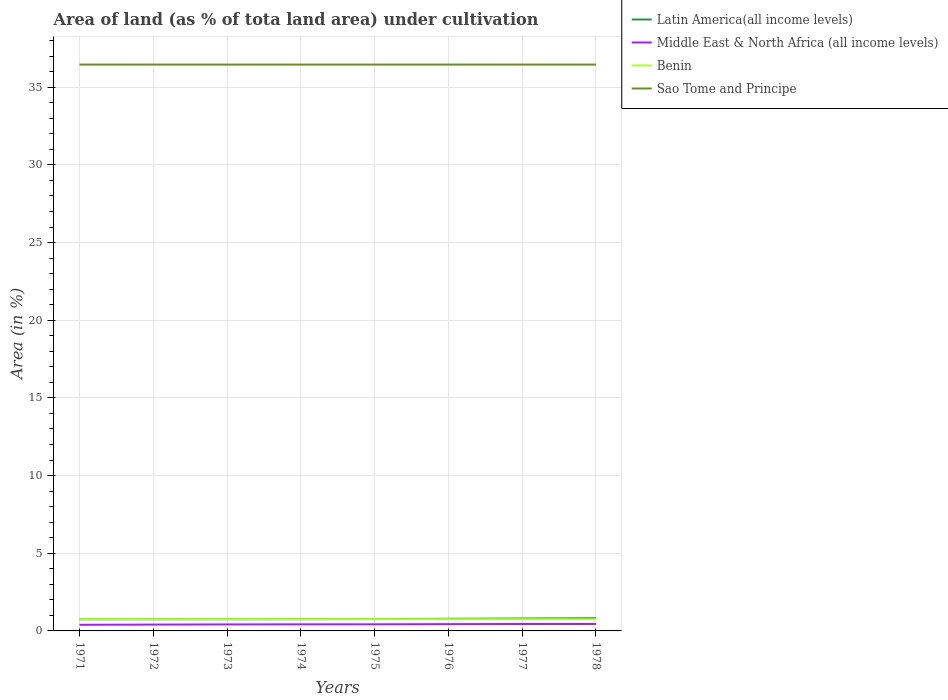Does the line corresponding to Middle East & North Africa (all income levels) intersect with the line corresponding to Latin America(all income levels)?
Give a very brief answer. No. Across all years, what is the maximum percentage of land under cultivation in Middle East & North Africa (all income levels)?
Make the answer very short. 0.39. What is the total percentage of land under cultivation in Latin America(all income levels) in the graph?
Provide a short and direct response. -0.06. What is the difference between the highest and the second highest percentage of land under cultivation in Latin America(all income levels)?
Provide a short and direct response. 0.07. Is the percentage of land under cultivation in Middle East & North Africa (all income levels) strictly greater than the percentage of land under cultivation in Benin over the years?
Your answer should be compact. Yes. How many lines are there?
Offer a very short reply. 4. How many years are there in the graph?
Your response must be concise. 8. What is the difference between two consecutive major ticks on the Y-axis?
Offer a terse response. 5. Does the graph contain any zero values?
Provide a short and direct response. No. Where does the legend appear in the graph?
Offer a terse response. Top right. How many legend labels are there?
Keep it short and to the point. 4. What is the title of the graph?
Ensure brevity in your answer.  Area of land (as % of tota land area) under cultivation. Does "Turkey" appear as one of the legend labels in the graph?
Offer a very short reply. No. What is the label or title of the X-axis?
Ensure brevity in your answer.  Years. What is the label or title of the Y-axis?
Provide a succinct answer. Area (in %). What is the Area (in %) in Latin America(all income levels) in 1971?
Ensure brevity in your answer.  0.75. What is the Area (in %) in Middle East & North Africa (all income levels) in 1971?
Make the answer very short. 0.39. What is the Area (in %) of Benin in 1971?
Keep it short and to the point. 0.75. What is the Area (in %) in Sao Tome and Principe in 1971?
Ensure brevity in your answer.  36.46. What is the Area (in %) of Latin America(all income levels) in 1972?
Your answer should be compact. 0.75. What is the Area (in %) of Middle East & North Africa (all income levels) in 1972?
Your answer should be compact. 0.41. What is the Area (in %) in Benin in 1972?
Keep it short and to the point. 0.75. What is the Area (in %) of Sao Tome and Principe in 1972?
Your response must be concise. 36.46. What is the Area (in %) of Latin America(all income levels) in 1973?
Provide a succinct answer. 0.76. What is the Area (in %) of Middle East & North Africa (all income levels) in 1973?
Give a very brief answer. 0.42. What is the Area (in %) in Benin in 1973?
Your response must be concise. 0.75. What is the Area (in %) of Sao Tome and Principe in 1973?
Offer a terse response. 36.46. What is the Area (in %) in Latin America(all income levels) in 1974?
Give a very brief answer. 0.76. What is the Area (in %) of Middle East & North Africa (all income levels) in 1974?
Your response must be concise. 0.42. What is the Area (in %) of Benin in 1974?
Make the answer very short. 0.75. What is the Area (in %) of Sao Tome and Principe in 1974?
Ensure brevity in your answer.  36.46. What is the Area (in %) in Latin America(all income levels) in 1975?
Provide a succinct answer. 0.76. What is the Area (in %) in Middle East & North Africa (all income levels) in 1975?
Your answer should be compact. 0.42. What is the Area (in %) of Benin in 1975?
Give a very brief answer. 0.75. What is the Area (in %) of Sao Tome and Principe in 1975?
Ensure brevity in your answer.  36.46. What is the Area (in %) of Latin America(all income levels) in 1976?
Keep it short and to the point. 0.78. What is the Area (in %) of Middle East & North Africa (all income levels) in 1976?
Give a very brief answer. 0.44. What is the Area (in %) of Benin in 1976?
Offer a very short reply. 0.75. What is the Area (in %) in Sao Tome and Principe in 1976?
Your answer should be very brief. 36.46. What is the Area (in %) of Latin America(all income levels) in 1977?
Your answer should be compact. 0.8. What is the Area (in %) in Middle East & North Africa (all income levels) in 1977?
Offer a terse response. 0.45. What is the Area (in %) in Benin in 1977?
Make the answer very short. 0.75. What is the Area (in %) in Sao Tome and Principe in 1977?
Your answer should be compact. 36.46. What is the Area (in %) of Latin America(all income levels) in 1978?
Your response must be concise. 0.82. What is the Area (in %) of Middle East & North Africa (all income levels) in 1978?
Offer a terse response. 0.45. What is the Area (in %) in Benin in 1978?
Ensure brevity in your answer.  0.75. What is the Area (in %) of Sao Tome and Principe in 1978?
Offer a very short reply. 36.46. Across all years, what is the maximum Area (in %) in Latin America(all income levels)?
Your answer should be very brief. 0.82. Across all years, what is the maximum Area (in %) in Middle East & North Africa (all income levels)?
Provide a short and direct response. 0.45. Across all years, what is the maximum Area (in %) in Benin?
Your response must be concise. 0.75. Across all years, what is the maximum Area (in %) of Sao Tome and Principe?
Your answer should be very brief. 36.46. Across all years, what is the minimum Area (in %) of Latin America(all income levels)?
Make the answer very short. 0.75. Across all years, what is the minimum Area (in %) of Middle East & North Africa (all income levels)?
Your answer should be very brief. 0.39. Across all years, what is the minimum Area (in %) of Benin?
Offer a very short reply. 0.75. Across all years, what is the minimum Area (in %) in Sao Tome and Principe?
Provide a short and direct response. 36.46. What is the total Area (in %) of Latin America(all income levels) in the graph?
Provide a short and direct response. 6.18. What is the total Area (in %) of Middle East & North Africa (all income levels) in the graph?
Provide a succinct answer. 3.39. What is the total Area (in %) of Benin in the graph?
Keep it short and to the point. 6.03. What is the total Area (in %) of Sao Tome and Principe in the graph?
Offer a very short reply. 291.67. What is the difference between the Area (in %) in Latin America(all income levels) in 1971 and that in 1972?
Your answer should be compact. -0. What is the difference between the Area (in %) in Middle East & North Africa (all income levels) in 1971 and that in 1972?
Provide a succinct answer. -0.01. What is the difference between the Area (in %) of Latin America(all income levels) in 1971 and that in 1973?
Keep it short and to the point. -0.01. What is the difference between the Area (in %) of Middle East & North Africa (all income levels) in 1971 and that in 1973?
Offer a very short reply. -0.02. What is the difference between the Area (in %) of Benin in 1971 and that in 1973?
Make the answer very short. 0. What is the difference between the Area (in %) of Latin America(all income levels) in 1971 and that in 1974?
Keep it short and to the point. -0.01. What is the difference between the Area (in %) of Middle East & North Africa (all income levels) in 1971 and that in 1974?
Give a very brief answer. -0.03. What is the difference between the Area (in %) in Latin America(all income levels) in 1971 and that in 1975?
Your answer should be very brief. -0.01. What is the difference between the Area (in %) in Middle East & North Africa (all income levels) in 1971 and that in 1975?
Make the answer very short. -0.03. What is the difference between the Area (in %) in Latin America(all income levels) in 1971 and that in 1976?
Make the answer very short. -0.03. What is the difference between the Area (in %) of Middle East & North Africa (all income levels) in 1971 and that in 1976?
Your answer should be very brief. -0.04. What is the difference between the Area (in %) of Benin in 1971 and that in 1976?
Give a very brief answer. 0. What is the difference between the Area (in %) in Latin America(all income levels) in 1971 and that in 1977?
Your response must be concise. -0.05. What is the difference between the Area (in %) in Middle East & North Africa (all income levels) in 1971 and that in 1977?
Offer a terse response. -0.05. What is the difference between the Area (in %) in Benin in 1971 and that in 1977?
Offer a very short reply. 0. What is the difference between the Area (in %) in Sao Tome and Principe in 1971 and that in 1977?
Your answer should be compact. 0. What is the difference between the Area (in %) of Latin America(all income levels) in 1971 and that in 1978?
Your answer should be compact. -0.07. What is the difference between the Area (in %) of Middle East & North Africa (all income levels) in 1971 and that in 1978?
Provide a short and direct response. -0.05. What is the difference between the Area (in %) of Sao Tome and Principe in 1971 and that in 1978?
Give a very brief answer. 0. What is the difference between the Area (in %) of Latin America(all income levels) in 1972 and that in 1973?
Your answer should be compact. -0. What is the difference between the Area (in %) in Middle East & North Africa (all income levels) in 1972 and that in 1973?
Give a very brief answer. -0.01. What is the difference between the Area (in %) of Benin in 1972 and that in 1973?
Provide a succinct answer. 0. What is the difference between the Area (in %) in Latin America(all income levels) in 1972 and that in 1974?
Ensure brevity in your answer.  -0. What is the difference between the Area (in %) in Middle East & North Africa (all income levels) in 1972 and that in 1974?
Your response must be concise. -0.02. What is the difference between the Area (in %) in Sao Tome and Principe in 1972 and that in 1974?
Your response must be concise. 0. What is the difference between the Area (in %) of Latin America(all income levels) in 1972 and that in 1975?
Make the answer very short. -0.01. What is the difference between the Area (in %) of Middle East & North Africa (all income levels) in 1972 and that in 1975?
Your response must be concise. -0.02. What is the difference between the Area (in %) in Latin America(all income levels) in 1972 and that in 1976?
Offer a very short reply. -0.03. What is the difference between the Area (in %) in Middle East & North Africa (all income levels) in 1972 and that in 1976?
Your answer should be very brief. -0.03. What is the difference between the Area (in %) in Benin in 1972 and that in 1976?
Offer a terse response. 0. What is the difference between the Area (in %) of Latin America(all income levels) in 1972 and that in 1977?
Your answer should be very brief. -0.04. What is the difference between the Area (in %) in Middle East & North Africa (all income levels) in 1972 and that in 1977?
Keep it short and to the point. -0.04. What is the difference between the Area (in %) in Benin in 1972 and that in 1977?
Offer a terse response. 0. What is the difference between the Area (in %) of Latin America(all income levels) in 1972 and that in 1978?
Ensure brevity in your answer.  -0.06. What is the difference between the Area (in %) in Middle East & North Africa (all income levels) in 1972 and that in 1978?
Keep it short and to the point. -0.04. What is the difference between the Area (in %) in Benin in 1972 and that in 1978?
Provide a succinct answer. 0. What is the difference between the Area (in %) in Sao Tome and Principe in 1972 and that in 1978?
Your answer should be very brief. 0. What is the difference between the Area (in %) in Latin America(all income levels) in 1973 and that in 1974?
Keep it short and to the point. -0. What is the difference between the Area (in %) of Middle East & North Africa (all income levels) in 1973 and that in 1974?
Give a very brief answer. -0.01. What is the difference between the Area (in %) of Benin in 1973 and that in 1974?
Give a very brief answer. 0. What is the difference between the Area (in %) in Latin America(all income levels) in 1973 and that in 1975?
Give a very brief answer. -0.01. What is the difference between the Area (in %) of Middle East & North Africa (all income levels) in 1973 and that in 1975?
Your answer should be compact. -0.01. What is the difference between the Area (in %) of Benin in 1973 and that in 1975?
Ensure brevity in your answer.  0. What is the difference between the Area (in %) in Latin America(all income levels) in 1973 and that in 1976?
Offer a terse response. -0.03. What is the difference between the Area (in %) in Middle East & North Africa (all income levels) in 1973 and that in 1976?
Provide a succinct answer. -0.02. What is the difference between the Area (in %) in Benin in 1973 and that in 1976?
Offer a very short reply. 0. What is the difference between the Area (in %) of Sao Tome and Principe in 1973 and that in 1976?
Provide a short and direct response. 0. What is the difference between the Area (in %) of Latin America(all income levels) in 1973 and that in 1977?
Keep it short and to the point. -0.04. What is the difference between the Area (in %) in Middle East & North Africa (all income levels) in 1973 and that in 1977?
Keep it short and to the point. -0.03. What is the difference between the Area (in %) of Benin in 1973 and that in 1977?
Your response must be concise. 0. What is the difference between the Area (in %) in Sao Tome and Principe in 1973 and that in 1977?
Your answer should be very brief. 0. What is the difference between the Area (in %) in Latin America(all income levels) in 1973 and that in 1978?
Ensure brevity in your answer.  -0.06. What is the difference between the Area (in %) in Middle East & North Africa (all income levels) in 1973 and that in 1978?
Your answer should be very brief. -0.03. What is the difference between the Area (in %) in Benin in 1973 and that in 1978?
Your answer should be very brief. 0. What is the difference between the Area (in %) in Latin America(all income levels) in 1974 and that in 1975?
Your answer should be very brief. -0.01. What is the difference between the Area (in %) of Middle East & North Africa (all income levels) in 1974 and that in 1975?
Offer a terse response. -0. What is the difference between the Area (in %) of Latin America(all income levels) in 1974 and that in 1976?
Your answer should be very brief. -0.02. What is the difference between the Area (in %) in Middle East & North Africa (all income levels) in 1974 and that in 1976?
Your response must be concise. -0.01. What is the difference between the Area (in %) in Benin in 1974 and that in 1976?
Your answer should be very brief. 0. What is the difference between the Area (in %) in Latin America(all income levels) in 1974 and that in 1977?
Make the answer very short. -0.04. What is the difference between the Area (in %) of Middle East & North Africa (all income levels) in 1974 and that in 1977?
Offer a very short reply. -0.02. What is the difference between the Area (in %) of Benin in 1974 and that in 1977?
Provide a short and direct response. 0. What is the difference between the Area (in %) of Sao Tome and Principe in 1974 and that in 1977?
Make the answer very short. 0. What is the difference between the Area (in %) of Latin America(all income levels) in 1974 and that in 1978?
Provide a succinct answer. -0.06. What is the difference between the Area (in %) of Middle East & North Africa (all income levels) in 1974 and that in 1978?
Ensure brevity in your answer.  -0.02. What is the difference between the Area (in %) in Benin in 1974 and that in 1978?
Keep it short and to the point. 0. What is the difference between the Area (in %) in Latin America(all income levels) in 1975 and that in 1976?
Offer a very short reply. -0.02. What is the difference between the Area (in %) in Middle East & North Africa (all income levels) in 1975 and that in 1976?
Your answer should be compact. -0.01. What is the difference between the Area (in %) of Sao Tome and Principe in 1975 and that in 1976?
Make the answer very short. 0. What is the difference between the Area (in %) of Latin America(all income levels) in 1975 and that in 1977?
Make the answer very short. -0.03. What is the difference between the Area (in %) in Middle East & North Africa (all income levels) in 1975 and that in 1977?
Your answer should be compact. -0.02. What is the difference between the Area (in %) in Latin America(all income levels) in 1975 and that in 1978?
Your response must be concise. -0.05. What is the difference between the Area (in %) of Middle East & North Africa (all income levels) in 1975 and that in 1978?
Ensure brevity in your answer.  -0.02. What is the difference between the Area (in %) in Benin in 1975 and that in 1978?
Make the answer very short. 0. What is the difference between the Area (in %) in Sao Tome and Principe in 1975 and that in 1978?
Offer a very short reply. 0. What is the difference between the Area (in %) of Latin America(all income levels) in 1976 and that in 1977?
Keep it short and to the point. -0.02. What is the difference between the Area (in %) of Middle East & North Africa (all income levels) in 1976 and that in 1977?
Give a very brief answer. -0.01. What is the difference between the Area (in %) in Sao Tome and Principe in 1976 and that in 1977?
Offer a very short reply. 0. What is the difference between the Area (in %) in Latin America(all income levels) in 1976 and that in 1978?
Give a very brief answer. -0.04. What is the difference between the Area (in %) of Middle East & North Africa (all income levels) in 1976 and that in 1978?
Provide a succinct answer. -0.01. What is the difference between the Area (in %) in Benin in 1976 and that in 1978?
Give a very brief answer. 0. What is the difference between the Area (in %) in Sao Tome and Principe in 1976 and that in 1978?
Your response must be concise. 0. What is the difference between the Area (in %) in Latin America(all income levels) in 1977 and that in 1978?
Your answer should be very brief. -0.02. What is the difference between the Area (in %) of Middle East & North Africa (all income levels) in 1977 and that in 1978?
Give a very brief answer. -0. What is the difference between the Area (in %) of Latin America(all income levels) in 1971 and the Area (in %) of Middle East & North Africa (all income levels) in 1972?
Make the answer very short. 0.34. What is the difference between the Area (in %) of Latin America(all income levels) in 1971 and the Area (in %) of Benin in 1972?
Give a very brief answer. -0. What is the difference between the Area (in %) in Latin America(all income levels) in 1971 and the Area (in %) in Sao Tome and Principe in 1972?
Offer a terse response. -35.71. What is the difference between the Area (in %) of Middle East & North Africa (all income levels) in 1971 and the Area (in %) of Benin in 1972?
Make the answer very short. -0.36. What is the difference between the Area (in %) of Middle East & North Africa (all income levels) in 1971 and the Area (in %) of Sao Tome and Principe in 1972?
Keep it short and to the point. -36.06. What is the difference between the Area (in %) of Benin in 1971 and the Area (in %) of Sao Tome and Principe in 1972?
Your answer should be very brief. -35.7. What is the difference between the Area (in %) of Latin America(all income levels) in 1971 and the Area (in %) of Middle East & North Africa (all income levels) in 1973?
Your answer should be compact. 0.33. What is the difference between the Area (in %) in Latin America(all income levels) in 1971 and the Area (in %) in Benin in 1973?
Keep it short and to the point. -0. What is the difference between the Area (in %) of Latin America(all income levels) in 1971 and the Area (in %) of Sao Tome and Principe in 1973?
Make the answer very short. -35.71. What is the difference between the Area (in %) of Middle East & North Africa (all income levels) in 1971 and the Area (in %) of Benin in 1973?
Your answer should be very brief. -0.36. What is the difference between the Area (in %) in Middle East & North Africa (all income levels) in 1971 and the Area (in %) in Sao Tome and Principe in 1973?
Provide a short and direct response. -36.06. What is the difference between the Area (in %) of Benin in 1971 and the Area (in %) of Sao Tome and Principe in 1973?
Your answer should be very brief. -35.7. What is the difference between the Area (in %) of Latin America(all income levels) in 1971 and the Area (in %) of Middle East & North Africa (all income levels) in 1974?
Your answer should be compact. 0.33. What is the difference between the Area (in %) in Latin America(all income levels) in 1971 and the Area (in %) in Benin in 1974?
Your answer should be very brief. -0. What is the difference between the Area (in %) of Latin America(all income levels) in 1971 and the Area (in %) of Sao Tome and Principe in 1974?
Ensure brevity in your answer.  -35.71. What is the difference between the Area (in %) of Middle East & North Africa (all income levels) in 1971 and the Area (in %) of Benin in 1974?
Provide a succinct answer. -0.36. What is the difference between the Area (in %) of Middle East & North Africa (all income levels) in 1971 and the Area (in %) of Sao Tome and Principe in 1974?
Provide a short and direct response. -36.06. What is the difference between the Area (in %) in Benin in 1971 and the Area (in %) in Sao Tome and Principe in 1974?
Ensure brevity in your answer.  -35.7. What is the difference between the Area (in %) in Latin America(all income levels) in 1971 and the Area (in %) in Middle East & North Africa (all income levels) in 1975?
Your answer should be very brief. 0.33. What is the difference between the Area (in %) in Latin America(all income levels) in 1971 and the Area (in %) in Benin in 1975?
Your answer should be compact. -0. What is the difference between the Area (in %) of Latin America(all income levels) in 1971 and the Area (in %) of Sao Tome and Principe in 1975?
Your answer should be very brief. -35.71. What is the difference between the Area (in %) in Middle East & North Africa (all income levels) in 1971 and the Area (in %) in Benin in 1975?
Ensure brevity in your answer.  -0.36. What is the difference between the Area (in %) of Middle East & North Africa (all income levels) in 1971 and the Area (in %) of Sao Tome and Principe in 1975?
Give a very brief answer. -36.06. What is the difference between the Area (in %) of Benin in 1971 and the Area (in %) of Sao Tome and Principe in 1975?
Provide a short and direct response. -35.7. What is the difference between the Area (in %) in Latin America(all income levels) in 1971 and the Area (in %) in Middle East & North Africa (all income levels) in 1976?
Your response must be concise. 0.31. What is the difference between the Area (in %) of Latin America(all income levels) in 1971 and the Area (in %) of Benin in 1976?
Make the answer very short. -0. What is the difference between the Area (in %) in Latin America(all income levels) in 1971 and the Area (in %) in Sao Tome and Principe in 1976?
Your answer should be compact. -35.71. What is the difference between the Area (in %) in Middle East & North Africa (all income levels) in 1971 and the Area (in %) in Benin in 1976?
Your answer should be compact. -0.36. What is the difference between the Area (in %) in Middle East & North Africa (all income levels) in 1971 and the Area (in %) in Sao Tome and Principe in 1976?
Provide a succinct answer. -36.06. What is the difference between the Area (in %) in Benin in 1971 and the Area (in %) in Sao Tome and Principe in 1976?
Your answer should be compact. -35.7. What is the difference between the Area (in %) in Latin America(all income levels) in 1971 and the Area (in %) in Middle East & North Africa (all income levels) in 1977?
Keep it short and to the point. 0.3. What is the difference between the Area (in %) of Latin America(all income levels) in 1971 and the Area (in %) of Benin in 1977?
Your answer should be compact. -0. What is the difference between the Area (in %) of Latin America(all income levels) in 1971 and the Area (in %) of Sao Tome and Principe in 1977?
Ensure brevity in your answer.  -35.71. What is the difference between the Area (in %) of Middle East & North Africa (all income levels) in 1971 and the Area (in %) of Benin in 1977?
Your response must be concise. -0.36. What is the difference between the Area (in %) of Middle East & North Africa (all income levels) in 1971 and the Area (in %) of Sao Tome and Principe in 1977?
Offer a very short reply. -36.06. What is the difference between the Area (in %) of Benin in 1971 and the Area (in %) of Sao Tome and Principe in 1977?
Provide a short and direct response. -35.7. What is the difference between the Area (in %) of Latin America(all income levels) in 1971 and the Area (in %) of Middle East & North Africa (all income levels) in 1978?
Provide a succinct answer. 0.3. What is the difference between the Area (in %) in Latin America(all income levels) in 1971 and the Area (in %) in Benin in 1978?
Your answer should be compact. -0. What is the difference between the Area (in %) in Latin America(all income levels) in 1971 and the Area (in %) in Sao Tome and Principe in 1978?
Your response must be concise. -35.71. What is the difference between the Area (in %) in Middle East & North Africa (all income levels) in 1971 and the Area (in %) in Benin in 1978?
Provide a short and direct response. -0.36. What is the difference between the Area (in %) of Middle East & North Africa (all income levels) in 1971 and the Area (in %) of Sao Tome and Principe in 1978?
Provide a succinct answer. -36.06. What is the difference between the Area (in %) of Benin in 1971 and the Area (in %) of Sao Tome and Principe in 1978?
Your answer should be compact. -35.7. What is the difference between the Area (in %) of Latin America(all income levels) in 1972 and the Area (in %) of Middle East & North Africa (all income levels) in 1973?
Offer a terse response. 0.34. What is the difference between the Area (in %) in Latin America(all income levels) in 1972 and the Area (in %) in Sao Tome and Principe in 1973?
Your answer should be very brief. -35.7. What is the difference between the Area (in %) in Middle East & North Africa (all income levels) in 1972 and the Area (in %) in Benin in 1973?
Your answer should be very brief. -0.35. What is the difference between the Area (in %) of Middle East & North Africa (all income levels) in 1972 and the Area (in %) of Sao Tome and Principe in 1973?
Give a very brief answer. -36.05. What is the difference between the Area (in %) of Benin in 1972 and the Area (in %) of Sao Tome and Principe in 1973?
Give a very brief answer. -35.7. What is the difference between the Area (in %) of Latin America(all income levels) in 1972 and the Area (in %) of Middle East & North Africa (all income levels) in 1974?
Provide a short and direct response. 0.33. What is the difference between the Area (in %) of Latin America(all income levels) in 1972 and the Area (in %) of Sao Tome and Principe in 1974?
Offer a terse response. -35.7. What is the difference between the Area (in %) in Middle East & North Africa (all income levels) in 1972 and the Area (in %) in Benin in 1974?
Your response must be concise. -0.35. What is the difference between the Area (in %) of Middle East & North Africa (all income levels) in 1972 and the Area (in %) of Sao Tome and Principe in 1974?
Your answer should be compact. -36.05. What is the difference between the Area (in %) in Benin in 1972 and the Area (in %) in Sao Tome and Principe in 1974?
Make the answer very short. -35.7. What is the difference between the Area (in %) of Latin America(all income levels) in 1972 and the Area (in %) of Middle East & North Africa (all income levels) in 1975?
Keep it short and to the point. 0.33. What is the difference between the Area (in %) of Latin America(all income levels) in 1972 and the Area (in %) of Benin in 1975?
Keep it short and to the point. 0. What is the difference between the Area (in %) of Latin America(all income levels) in 1972 and the Area (in %) of Sao Tome and Principe in 1975?
Keep it short and to the point. -35.7. What is the difference between the Area (in %) in Middle East & North Africa (all income levels) in 1972 and the Area (in %) in Benin in 1975?
Ensure brevity in your answer.  -0.35. What is the difference between the Area (in %) in Middle East & North Africa (all income levels) in 1972 and the Area (in %) in Sao Tome and Principe in 1975?
Your response must be concise. -36.05. What is the difference between the Area (in %) of Benin in 1972 and the Area (in %) of Sao Tome and Principe in 1975?
Offer a terse response. -35.7. What is the difference between the Area (in %) in Latin America(all income levels) in 1972 and the Area (in %) in Middle East & North Africa (all income levels) in 1976?
Ensure brevity in your answer.  0.32. What is the difference between the Area (in %) in Latin America(all income levels) in 1972 and the Area (in %) in Benin in 1976?
Make the answer very short. 0. What is the difference between the Area (in %) of Latin America(all income levels) in 1972 and the Area (in %) of Sao Tome and Principe in 1976?
Your answer should be compact. -35.7. What is the difference between the Area (in %) in Middle East & North Africa (all income levels) in 1972 and the Area (in %) in Benin in 1976?
Provide a succinct answer. -0.35. What is the difference between the Area (in %) in Middle East & North Africa (all income levels) in 1972 and the Area (in %) in Sao Tome and Principe in 1976?
Ensure brevity in your answer.  -36.05. What is the difference between the Area (in %) in Benin in 1972 and the Area (in %) in Sao Tome and Principe in 1976?
Your answer should be very brief. -35.7. What is the difference between the Area (in %) in Latin America(all income levels) in 1972 and the Area (in %) in Middle East & North Africa (all income levels) in 1977?
Your answer should be very brief. 0.31. What is the difference between the Area (in %) of Latin America(all income levels) in 1972 and the Area (in %) of Benin in 1977?
Give a very brief answer. 0. What is the difference between the Area (in %) in Latin America(all income levels) in 1972 and the Area (in %) in Sao Tome and Principe in 1977?
Offer a terse response. -35.7. What is the difference between the Area (in %) of Middle East & North Africa (all income levels) in 1972 and the Area (in %) of Benin in 1977?
Offer a very short reply. -0.35. What is the difference between the Area (in %) in Middle East & North Africa (all income levels) in 1972 and the Area (in %) in Sao Tome and Principe in 1977?
Your response must be concise. -36.05. What is the difference between the Area (in %) in Benin in 1972 and the Area (in %) in Sao Tome and Principe in 1977?
Provide a succinct answer. -35.7. What is the difference between the Area (in %) of Latin America(all income levels) in 1972 and the Area (in %) of Middle East & North Africa (all income levels) in 1978?
Your response must be concise. 0.31. What is the difference between the Area (in %) of Latin America(all income levels) in 1972 and the Area (in %) of Sao Tome and Principe in 1978?
Make the answer very short. -35.7. What is the difference between the Area (in %) of Middle East & North Africa (all income levels) in 1972 and the Area (in %) of Benin in 1978?
Keep it short and to the point. -0.35. What is the difference between the Area (in %) in Middle East & North Africa (all income levels) in 1972 and the Area (in %) in Sao Tome and Principe in 1978?
Your answer should be very brief. -36.05. What is the difference between the Area (in %) of Benin in 1972 and the Area (in %) of Sao Tome and Principe in 1978?
Your response must be concise. -35.7. What is the difference between the Area (in %) in Latin America(all income levels) in 1973 and the Area (in %) in Middle East & North Africa (all income levels) in 1974?
Provide a short and direct response. 0.33. What is the difference between the Area (in %) of Latin America(all income levels) in 1973 and the Area (in %) of Benin in 1974?
Give a very brief answer. 0. What is the difference between the Area (in %) of Latin America(all income levels) in 1973 and the Area (in %) of Sao Tome and Principe in 1974?
Your response must be concise. -35.7. What is the difference between the Area (in %) in Middle East & North Africa (all income levels) in 1973 and the Area (in %) in Benin in 1974?
Provide a succinct answer. -0.34. What is the difference between the Area (in %) of Middle East & North Africa (all income levels) in 1973 and the Area (in %) of Sao Tome and Principe in 1974?
Offer a terse response. -36.04. What is the difference between the Area (in %) of Benin in 1973 and the Area (in %) of Sao Tome and Principe in 1974?
Provide a short and direct response. -35.7. What is the difference between the Area (in %) in Latin America(all income levels) in 1973 and the Area (in %) in Middle East & North Africa (all income levels) in 1975?
Give a very brief answer. 0.33. What is the difference between the Area (in %) in Latin America(all income levels) in 1973 and the Area (in %) in Benin in 1975?
Your answer should be very brief. 0. What is the difference between the Area (in %) of Latin America(all income levels) in 1973 and the Area (in %) of Sao Tome and Principe in 1975?
Provide a succinct answer. -35.7. What is the difference between the Area (in %) of Middle East & North Africa (all income levels) in 1973 and the Area (in %) of Benin in 1975?
Your answer should be very brief. -0.34. What is the difference between the Area (in %) in Middle East & North Africa (all income levels) in 1973 and the Area (in %) in Sao Tome and Principe in 1975?
Your answer should be very brief. -36.04. What is the difference between the Area (in %) of Benin in 1973 and the Area (in %) of Sao Tome and Principe in 1975?
Provide a succinct answer. -35.7. What is the difference between the Area (in %) in Latin America(all income levels) in 1973 and the Area (in %) in Middle East & North Africa (all income levels) in 1976?
Keep it short and to the point. 0.32. What is the difference between the Area (in %) of Latin America(all income levels) in 1973 and the Area (in %) of Benin in 1976?
Make the answer very short. 0. What is the difference between the Area (in %) of Latin America(all income levels) in 1973 and the Area (in %) of Sao Tome and Principe in 1976?
Give a very brief answer. -35.7. What is the difference between the Area (in %) of Middle East & North Africa (all income levels) in 1973 and the Area (in %) of Benin in 1976?
Keep it short and to the point. -0.34. What is the difference between the Area (in %) in Middle East & North Africa (all income levels) in 1973 and the Area (in %) in Sao Tome and Principe in 1976?
Give a very brief answer. -36.04. What is the difference between the Area (in %) of Benin in 1973 and the Area (in %) of Sao Tome and Principe in 1976?
Give a very brief answer. -35.7. What is the difference between the Area (in %) in Latin America(all income levels) in 1973 and the Area (in %) in Middle East & North Africa (all income levels) in 1977?
Your response must be concise. 0.31. What is the difference between the Area (in %) in Latin America(all income levels) in 1973 and the Area (in %) in Benin in 1977?
Offer a very short reply. 0. What is the difference between the Area (in %) in Latin America(all income levels) in 1973 and the Area (in %) in Sao Tome and Principe in 1977?
Offer a terse response. -35.7. What is the difference between the Area (in %) in Middle East & North Africa (all income levels) in 1973 and the Area (in %) in Benin in 1977?
Provide a succinct answer. -0.34. What is the difference between the Area (in %) of Middle East & North Africa (all income levels) in 1973 and the Area (in %) of Sao Tome and Principe in 1977?
Keep it short and to the point. -36.04. What is the difference between the Area (in %) of Benin in 1973 and the Area (in %) of Sao Tome and Principe in 1977?
Offer a very short reply. -35.7. What is the difference between the Area (in %) in Latin America(all income levels) in 1973 and the Area (in %) in Middle East & North Africa (all income levels) in 1978?
Your answer should be compact. 0.31. What is the difference between the Area (in %) in Latin America(all income levels) in 1973 and the Area (in %) in Benin in 1978?
Ensure brevity in your answer.  0. What is the difference between the Area (in %) of Latin America(all income levels) in 1973 and the Area (in %) of Sao Tome and Principe in 1978?
Your response must be concise. -35.7. What is the difference between the Area (in %) in Middle East & North Africa (all income levels) in 1973 and the Area (in %) in Benin in 1978?
Ensure brevity in your answer.  -0.34. What is the difference between the Area (in %) of Middle East & North Africa (all income levels) in 1973 and the Area (in %) of Sao Tome and Principe in 1978?
Offer a terse response. -36.04. What is the difference between the Area (in %) of Benin in 1973 and the Area (in %) of Sao Tome and Principe in 1978?
Offer a terse response. -35.7. What is the difference between the Area (in %) of Latin America(all income levels) in 1974 and the Area (in %) of Middle East & North Africa (all income levels) in 1975?
Offer a terse response. 0.33. What is the difference between the Area (in %) of Latin America(all income levels) in 1974 and the Area (in %) of Benin in 1975?
Your answer should be compact. 0. What is the difference between the Area (in %) of Latin America(all income levels) in 1974 and the Area (in %) of Sao Tome and Principe in 1975?
Provide a short and direct response. -35.7. What is the difference between the Area (in %) of Middle East & North Africa (all income levels) in 1974 and the Area (in %) of Benin in 1975?
Your response must be concise. -0.33. What is the difference between the Area (in %) of Middle East & North Africa (all income levels) in 1974 and the Area (in %) of Sao Tome and Principe in 1975?
Your answer should be compact. -36.04. What is the difference between the Area (in %) of Benin in 1974 and the Area (in %) of Sao Tome and Principe in 1975?
Offer a terse response. -35.7. What is the difference between the Area (in %) in Latin America(all income levels) in 1974 and the Area (in %) in Middle East & North Africa (all income levels) in 1976?
Make the answer very short. 0.32. What is the difference between the Area (in %) of Latin America(all income levels) in 1974 and the Area (in %) of Benin in 1976?
Offer a very short reply. 0. What is the difference between the Area (in %) in Latin America(all income levels) in 1974 and the Area (in %) in Sao Tome and Principe in 1976?
Your answer should be very brief. -35.7. What is the difference between the Area (in %) in Middle East & North Africa (all income levels) in 1974 and the Area (in %) in Benin in 1976?
Offer a very short reply. -0.33. What is the difference between the Area (in %) in Middle East & North Africa (all income levels) in 1974 and the Area (in %) in Sao Tome and Principe in 1976?
Provide a succinct answer. -36.04. What is the difference between the Area (in %) in Benin in 1974 and the Area (in %) in Sao Tome and Principe in 1976?
Provide a succinct answer. -35.7. What is the difference between the Area (in %) of Latin America(all income levels) in 1974 and the Area (in %) of Middle East & North Africa (all income levels) in 1977?
Ensure brevity in your answer.  0.31. What is the difference between the Area (in %) of Latin America(all income levels) in 1974 and the Area (in %) of Benin in 1977?
Make the answer very short. 0. What is the difference between the Area (in %) of Latin America(all income levels) in 1974 and the Area (in %) of Sao Tome and Principe in 1977?
Provide a succinct answer. -35.7. What is the difference between the Area (in %) in Middle East & North Africa (all income levels) in 1974 and the Area (in %) in Benin in 1977?
Your answer should be compact. -0.33. What is the difference between the Area (in %) of Middle East & North Africa (all income levels) in 1974 and the Area (in %) of Sao Tome and Principe in 1977?
Offer a terse response. -36.04. What is the difference between the Area (in %) in Benin in 1974 and the Area (in %) in Sao Tome and Principe in 1977?
Make the answer very short. -35.7. What is the difference between the Area (in %) of Latin America(all income levels) in 1974 and the Area (in %) of Middle East & North Africa (all income levels) in 1978?
Provide a succinct answer. 0.31. What is the difference between the Area (in %) of Latin America(all income levels) in 1974 and the Area (in %) of Benin in 1978?
Provide a short and direct response. 0. What is the difference between the Area (in %) of Latin America(all income levels) in 1974 and the Area (in %) of Sao Tome and Principe in 1978?
Offer a terse response. -35.7. What is the difference between the Area (in %) of Middle East & North Africa (all income levels) in 1974 and the Area (in %) of Benin in 1978?
Your answer should be very brief. -0.33. What is the difference between the Area (in %) in Middle East & North Africa (all income levels) in 1974 and the Area (in %) in Sao Tome and Principe in 1978?
Give a very brief answer. -36.04. What is the difference between the Area (in %) in Benin in 1974 and the Area (in %) in Sao Tome and Principe in 1978?
Your response must be concise. -35.7. What is the difference between the Area (in %) in Latin America(all income levels) in 1975 and the Area (in %) in Middle East & North Africa (all income levels) in 1976?
Provide a succinct answer. 0.33. What is the difference between the Area (in %) in Latin America(all income levels) in 1975 and the Area (in %) in Benin in 1976?
Provide a short and direct response. 0.01. What is the difference between the Area (in %) in Latin America(all income levels) in 1975 and the Area (in %) in Sao Tome and Principe in 1976?
Your answer should be very brief. -35.69. What is the difference between the Area (in %) in Middle East & North Africa (all income levels) in 1975 and the Area (in %) in Benin in 1976?
Offer a terse response. -0.33. What is the difference between the Area (in %) of Middle East & North Africa (all income levels) in 1975 and the Area (in %) of Sao Tome and Principe in 1976?
Your response must be concise. -36.03. What is the difference between the Area (in %) in Benin in 1975 and the Area (in %) in Sao Tome and Principe in 1976?
Provide a succinct answer. -35.7. What is the difference between the Area (in %) of Latin America(all income levels) in 1975 and the Area (in %) of Middle East & North Africa (all income levels) in 1977?
Offer a terse response. 0.32. What is the difference between the Area (in %) in Latin America(all income levels) in 1975 and the Area (in %) in Benin in 1977?
Offer a very short reply. 0.01. What is the difference between the Area (in %) of Latin America(all income levels) in 1975 and the Area (in %) of Sao Tome and Principe in 1977?
Ensure brevity in your answer.  -35.69. What is the difference between the Area (in %) of Middle East & North Africa (all income levels) in 1975 and the Area (in %) of Benin in 1977?
Your answer should be very brief. -0.33. What is the difference between the Area (in %) in Middle East & North Africa (all income levels) in 1975 and the Area (in %) in Sao Tome and Principe in 1977?
Your answer should be compact. -36.03. What is the difference between the Area (in %) of Benin in 1975 and the Area (in %) of Sao Tome and Principe in 1977?
Keep it short and to the point. -35.7. What is the difference between the Area (in %) in Latin America(all income levels) in 1975 and the Area (in %) in Middle East & North Africa (all income levels) in 1978?
Provide a short and direct response. 0.32. What is the difference between the Area (in %) in Latin America(all income levels) in 1975 and the Area (in %) in Benin in 1978?
Your answer should be very brief. 0.01. What is the difference between the Area (in %) in Latin America(all income levels) in 1975 and the Area (in %) in Sao Tome and Principe in 1978?
Make the answer very short. -35.69. What is the difference between the Area (in %) in Middle East & North Africa (all income levels) in 1975 and the Area (in %) in Benin in 1978?
Offer a terse response. -0.33. What is the difference between the Area (in %) of Middle East & North Africa (all income levels) in 1975 and the Area (in %) of Sao Tome and Principe in 1978?
Offer a terse response. -36.03. What is the difference between the Area (in %) in Benin in 1975 and the Area (in %) in Sao Tome and Principe in 1978?
Ensure brevity in your answer.  -35.7. What is the difference between the Area (in %) in Latin America(all income levels) in 1976 and the Area (in %) in Middle East & North Africa (all income levels) in 1977?
Provide a succinct answer. 0.34. What is the difference between the Area (in %) of Latin America(all income levels) in 1976 and the Area (in %) of Benin in 1977?
Provide a succinct answer. 0.03. What is the difference between the Area (in %) of Latin America(all income levels) in 1976 and the Area (in %) of Sao Tome and Principe in 1977?
Give a very brief answer. -35.68. What is the difference between the Area (in %) of Middle East & North Africa (all income levels) in 1976 and the Area (in %) of Benin in 1977?
Make the answer very short. -0.32. What is the difference between the Area (in %) of Middle East & North Africa (all income levels) in 1976 and the Area (in %) of Sao Tome and Principe in 1977?
Make the answer very short. -36.02. What is the difference between the Area (in %) of Benin in 1976 and the Area (in %) of Sao Tome and Principe in 1977?
Make the answer very short. -35.7. What is the difference between the Area (in %) in Latin America(all income levels) in 1976 and the Area (in %) in Middle East & North Africa (all income levels) in 1978?
Provide a succinct answer. 0.33. What is the difference between the Area (in %) in Latin America(all income levels) in 1976 and the Area (in %) in Benin in 1978?
Your response must be concise. 0.03. What is the difference between the Area (in %) in Latin America(all income levels) in 1976 and the Area (in %) in Sao Tome and Principe in 1978?
Make the answer very short. -35.68. What is the difference between the Area (in %) in Middle East & North Africa (all income levels) in 1976 and the Area (in %) in Benin in 1978?
Provide a short and direct response. -0.32. What is the difference between the Area (in %) in Middle East & North Africa (all income levels) in 1976 and the Area (in %) in Sao Tome and Principe in 1978?
Offer a very short reply. -36.02. What is the difference between the Area (in %) in Benin in 1976 and the Area (in %) in Sao Tome and Principe in 1978?
Offer a very short reply. -35.7. What is the difference between the Area (in %) in Latin America(all income levels) in 1977 and the Area (in %) in Middle East & North Africa (all income levels) in 1978?
Provide a succinct answer. 0.35. What is the difference between the Area (in %) of Latin America(all income levels) in 1977 and the Area (in %) of Benin in 1978?
Give a very brief answer. 0.04. What is the difference between the Area (in %) in Latin America(all income levels) in 1977 and the Area (in %) in Sao Tome and Principe in 1978?
Your answer should be compact. -35.66. What is the difference between the Area (in %) in Middle East & North Africa (all income levels) in 1977 and the Area (in %) in Benin in 1978?
Provide a succinct answer. -0.31. What is the difference between the Area (in %) of Middle East & North Africa (all income levels) in 1977 and the Area (in %) of Sao Tome and Principe in 1978?
Keep it short and to the point. -36.01. What is the difference between the Area (in %) of Benin in 1977 and the Area (in %) of Sao Tome and Principe in 1978?
Make the answer very short. -35.7. What is the average Area (in %) of Latin America(all income levels) per year?
Ensure brevity in your answer.  0.77. What is the average Area (in %) of Middle East & North Africa (all income levels) per year?
Offer a very short reply. 0.42. What is the average Area (in %) in Benin per year?
Provide a succinct answer. 0.75. What is the average Area (in %) of Sao Tome and Principe per year?
Offer a terse response. 36.46. In the year 1971, what is the difference between the Area (in %) of Latin America(all income levels) and Area (in %) of Middle East & North Africa (all income levels)?
Provide a short and direct response. 0.36. In the year 1971, what is the difference between the Area (in %) in Latin America(all income levels) and Area (in %) in Benin?
Keep it short and to the point. -0. In the year 1971, what is the difference between the Area (in %) in Latin America(all income levels) and Area (in %) in Sao Tome and Principe?
Your response must be concise. -35.71. In the year 1971, what is the difference between the Area (in %) in Middle East & North Africa (all income levels) and Area (in %) in Benin?
Your answer should be very brief. -0.36. In the year 1971, what is the difference between the Area (in %) of Middle East & North Africa (all income levels) and Area (in %) of Sao Tome and Principe?
Provide a short and direct response. -36.06. In the year 1971, what is the difference between the Area (in %) of Benin and Area (in %) of Sao Tome and Principe?
Your answer should be very brief. -35.7. In the year 1972, what is the difference between the Area (in %) in Latin America(all income levels) and Area (in %) in Middle East & North Africa (all income levels)?
Offer a very short reply. 0.35. In the year 1972, what is the difference between the Area (in %) in Latin America(all income levels) and Area (in %) in Sao Tome and Principe?
Your answer should be very brief. -35.7. In the year 1972, what is the difference between the Area (in %) in Middle East & North Africa (all income levels) and Area (in %) in Benin?
Provide a short and direct response. -0.35. In the year 1972, what is the difference between the Area (in %) of Middle East & North Africa (all income levels) and Area (in %) of Sao Tome and Principe?
Keep it short and to the point. -36.05. In the year 1972, what is the difference between the Area (in %) in Benin and Area (in %) in Sao Tome and Principe?
Give a very brief answer. -35.7. In the year 1973, what is the difference between the Area (in %) of Latin America(all income levels) and Area (in %) of Middle East & North Africa (all income levels)?
Offer a very short reply. 0.34. In the year 1973, what is the difference between the Area (in %) in Latin America(all income levels) and Area (in %) in Benin?
Offer a very short reply. 0. In the year 1973, what is the difference between the Area (in %) of Latin America(all income levels) and Area (in %) of Sao Tome and Principe?
Keep it short and to the point. -35.7. In the year 1973, what is the difference between the Area (in %) of Middle East & North Africa (all income levels) and Area (in %) of Benin?
Make the answer very short. -0.34. In the year 1973, what is the difference between the Area (in %) in Middle East & North Africa (all income levels) and Area (in %) in Sao Tome and Principe?
Give a very brief answer. -36.04. In the year 1973, what is the difference between the Area (in %) in Benin and Area (in %) in Sao Tome and Principe?
Provide a succinct answer. -35.7. In the year 1974, what is the difference between the Area (in %) in Latin America(all income levels) and Area (in %) in Middle East & North Africa (all income levels)?
Your answer should be compact. 0.33. In the year 1974, what is the difference between the Area (in %) in Latin America(all income levels) and Area (in %) in Benin?
Provide a short and direct response. 0. In the year 1974, what is the difference between the Area (in %) of Latin America(all income levels) and Area (in %) of Sao Tome and Principe?
Make the answer very short. -35.7. In the year 1974, what is the difference between the Area (in %) of Middle East & North Africa (all income levels) and Area (in %) of Benin?
Offer a terse response. -0.33. In the year 1974, what is the difference between the Area (in %) of Middle East & North Africa (all income levels) and Area (in %) of Sao Tome and Principe?
Keep it short and to the point. -36.04. In the year 1974, what is the difference between the Area (in %) of Benin and Area (in %) of Sao Tome and Principe?
Ensure brevity in your answer.  -35.7. In the year 1975, what is the difference between the Area (in %) of Latin America(all income levels) and Area (in %) of Middle East & North Africa (all income levels)?
Your answer should be compact. 0.34. In the year 1975, what is the difference between the Area (in %) in Latin America(all income levels) and Area (in %) in Benin?
Offer a very short reply. 0.01. In the year 1975, what is the difference between the Area (in %) in Latin America(all income levels) and Area (in %) in Sao Tome and Principe?
Provide a short and direct response. -35.69. In the year 1975, what is the difference between the Area (in %) of Middle East & North Africa (all income levels) and Area (in %) of Benin?
Ensure brevity in your answer.  -0.33. In the year 1975, what is the difference between the Area (in %) in Middle East & North Africa (all income levels) and Area (in %) in Sao Tome and Principe?
Keep it short and to the point. -36.03. In the year 1975, what is the difference between the Area (in %) of Benin and Area (in %) of Sao Tome and Principe?
Your answer should be very brief. -35.7. In the year 1976, what is the difference between the Area (in %) in Latin America(all income levels) and Area (in %) in Middle East & North Africa (all income levels)?
Your response must be concise. 0.35. In the year 1976, what is the difference between the Area (in %) of Latin America(all income levels) and Area (in %) of Benin?
Offer a terse response. 0.03. In the year 1976, what is the difference between the Area (in %) of Latin America(all income levels) and Area (in %) of Sao Tome and Principe?
Make the answer very short. -35.68. In the year 1976, what is the difference between the Area (in %) in Middle East & North Africa (all income levels) and Area (in %) in Benin?
Offer a terse response. -0.32. In the year 1976, what is the difference between the Area (in %) in Middle East & North Africa (all income levels) and Area (in %) in Sao Tome and Principe?
Offer a very short reply. -36.02. In the year 1976, what is the difference between the Area (in %) of Benin and Area (in %) of Sao Tome and Principe?
Provide a succinct answer. -35.7. In the year 1977, what is the difference between the Area (in %) of Latin America(all income levels) and Area (in %) of Middle East & North Africa (all income levels)?
Offer a very short reply. 0.35. In the year 1977, what is the difference between the Area (in %) of Latin America(all income levels) and Area (in %) of Benin?
Provide a succinct answer. 0.04. In the year 1977, what is the difference between the Area (in %) in Latin America(all income levels) and Area (in %) in Sao Tome and Principe?
Ensure brevity in your answer.  -35.66. In the year 1977, what is the difference between the Area (in %) of Middle East & North Africa (all income levels) and Area (in %) of Benin?
Your response must be concise. -0.31. In the year 1977, what is the difference between the Area (in %) of Middle East & North Africa (all income levels) and Area (in %) of Sao Tome and Principe?
Your answer should be very brief. -36.01. In the year 1977, what is the difference between the Area (in %) in Benin and Area (in %) in Sao Tome and Principe?
Provide a short and direct response. -35.7. In the year 1978, what is the difference between the Area (in %) of Latin America(all income levels) and Area (in %) of Middle East & North Africa (all income levels)?
Your answer should be compact. 0.37. In the year 1978, what is the difference between the Area (in %) of Latin America(all income levels) and Area (in %) of Benin?
Make the answer very short. 0.06. In the year 1978, what is the difference between the Area (in %) in Latin America(all income levels) and Area (in %) in Sao Tome and Principe?
Your answer should be compact. -35.64. In the year 1978, what is the difference between the Area (in %) in Middle East & North Africa (all income levels) and Area (in %) in Benin?
Offer a very short reply. -0.31. In the year 1978, what is the difference between the Area (in %) of Middle East & North Africa (all income levels) and Area (in %) of Sao Tome and Principe?
Your answer should be very brief. -36.01. In the year 1978, what is the difference between the Area (in %) in Benin and Area (in %) in Sao Tome and Principe?
Your answer should be very brief. -35.7. What is the ratio of the Area (in %) in Latin America(all income levels) in 1971 to that in 1972?
Offer a very short reply. 0.99. What is the ratio of the Area (in %) of Middle East & North Africa (all income levels) in 1971 to that in 1972?
Make the answer very short. 0.97. What is the ratio of the Area (in %) in Latin America(all income levels) in 1971 to that in 1973?
Your response must be concise. 0.99. What is the ratio of the Area (in %) in Middle East & North Africa (all income levels) in 1971 to that in 1973?
Ensure brevity in your answer.  0.94. What is the ratio of the Area (in %) in Benin in 1971 to that in 1973?
Provide a succinct answer. 1. What is the ratio of the Area (in %) of Latin America(all income levels) in 1971 to that in 1974?
Keep it short and to the point. 0.99. What is the ratio of the Area (in %) of Middle East & North Africa (all income levels) in 1971 to that in 1974?
Provide a succinct answer. 0.93. What is the ratio of the Area (in %) in Latin America(all income levels) in 1971 to that in 1975?
Your answer should be compact. 0.98. What is the ratio of the Area (in %) in Middle East & North Africa (all income levels) in 1971 to that in 1975?
Provide a short and direct response. 0.93. What is the ratio of the Area (in %) of Benin in 1971 to that in 1975?
Give a very brief answer. 1. What is the ratio of the Area (in %) of Latin America(all income levels) in 1971 to that in 1976?
Your answer should be very brief. 0.96. What is the ratio of the Area (in %) in Middle East & North Africa (all income levels) in 1971 to that in 1976?
Offer a terse response. 0.91. What is the ratio of the Area (in %) in Benin in 1971 to that in 1976?
Your answer should be very brief. 1. What is the ratio of the Area (in %) of Latin America(all income levels) in 1971 to that in 1977?
Your response must be concise. 0.94. What is the ratio of the Area (in %) in Middle East & North Africa (all income levels) in 1971 to that in 1977?
Your response must be concise. 0.88. What is the ratio of the Area (in %) of Benin in 1971 to that in 1977?
Offer a very short reply. 1. What is the ratio of the Area (in %) in Sao Tome and Principe in 1971 to that in 1977?
Keep it short and to the point. 1. What is the ratio of the Area (in %) of Latin America(all income levels) in 1971 to that in 1978?
Your answer should be very brief. 0.92. What is the ratio of the Area (in %) in Middle East & North Africa (all income levels) in 1971 to that in 1978?
Offer a very short reply. 0.88. What is the ratio of the Area (in %) in Benin in 1971 to that in 1978?
Keep it short and to the point. 1. What is the ratio of the Area (in %) in Sao Tome and Principe in 1971 to that in 1978?
Offer a terse response. 1. What is the ratio of the Area (in %) in Middle East & North Africa (all income levels) in 1972 to that in 1973?
Give a very brief answer. 0.97. What is the ratio of the Area (in %) of Middle East & North Africa (all income levels) in 1972 to that in 1974?
Your answer should be very brief. 0.96. What is the ratio of the Area (in %) in Benin in 1972 to that in 1974?
Your response must be concise. 1. What is the ratio of the Area (in %) in Sao Tome and Principe in 1972 to that in 1974?
Ensure brevity in your answer.  1. What is the ratio of the Area (in %) of Latin America(all income levels) in 1972 to that in 1975?
Offer a very short reply. 0.99. What is the ratio of the Area (in %) of Middle East & North Africa (all income levels) in 1972 to that in 1975?
Keep it short and to the point. 0.96. What is the ratio of the Area (in %) of Benin in 1972 to that in 1975?
Your answer should be very brief. 1. What is the ratio of the Area (in %) of Sao Tome and Principe in 1972 to that in 1975?
Give a very brief answer. 1. What is the ratio of the Area (in %) of Latin America(all income levels) in 1972 to that in 1976?
Provide a succinct answer. 0.97. What is the ratio of the Area (in %) of Middle East & North Africa (all income levels) in 1972 to that in 1976?
Provide a short and direct response. 0.94. What is the ratio of the Area (in %) of Benin in 1972 to that in 1976?
Make the answer very short. 1. What is the ratio of the Area (in %) of Sao Tome and Principe in 1972 to that in 1976?
Your answer should be compact. 1. What is the ratio of the Area (in %) in Latin America(all income levels) in 1972 to that in 1977?
Offer a terse response. 0.94. What is the ratio of the Area (in %) in Middle East & North Africa (all income levels) in 1972 to that in 1977?
Give a very brief answer. 0.91. What is the ratio of the Area (in %) of Sao Tome and Principe in 1972 to that in 1977?
Keep it short and to the point. 1. What is the ratio of the Area (in %) of Latin America(all income levels) in 1972 to that in 1978?
Give a very brief answer. 0.92. What is the ratio of the Area (in %) in Middle East & North Africa (all income levels) in 1972 to that in 1978?
Keep it short and to the point. 0.91. What is the ratio of the Area (in %) of Benin in 1972 to that in 1978?
Provide a succinct answer. 1. What is the ratio of the Area (in %) in Latin America(all income levels) in 1973 to that in 1974?
Offer a terse response. 1. What is the ratio of the Area (in %) in Middle East & North Africa (all income levels) in 1973 to that in 1974?
Provide a short and direct response. 0.99. What is the ratio of the Area (in %) of Latin America(all income levels) in 1973 to that in 1975?
Ensure brevity in your answer.  0.99. What is the ratio of the Area (in %) of Middle East & North Africa (all income levels) in 1973 to that in 1975?
Give a very brief answer. 0.98. What is the ratio of the Area (in %) of Benin in 1973 to that in 1975?
Offer a very short reply. 1. What is the ratio of the Area (in %) of Sao Tome and Principe in 1973 to that in 1975?
Your answer should be compact. 1. What is the ratio of the Area (in %) in Latin America(all income levels) in 1973 to that in 1976?
Give a very brief answer. 0.97. What is the ratio of the Area (in %) in Middle East & North Africa (all income levels) in 1973 to that in 1976?
Offer a very short reply. 0.96. What is the ratio of the Area (in %) in Sao Tome and Principe in 1973 to that in 1976?
Your answer should be very brief. 1. What is the ratio of the Area (in %) of Latin America(all income levels) in 1973 to that in 1977?
Your answer should be very brief. 0.95. What is the ratio of the Area (in %) in Middle East & North Africa (all income levels) in 1973 to that in 1977?
Provide a succinct answer. 0.94. What is the ratio of the Area (in %) of Benin in 1973 to that in 1977?
Ensure brevity in your answer.  1. What is the ratio of the Area (in %) of Latin America(all income levels) in 1973 to that in 1978?
Offer a terse response. 0.92. What is the ratio of the Area (in %) of Middle East & North Africa (all income levels) in 1973 to that in 1978?
Your answer should be compact. 0.94. What is the ratio of the Area (in %) of Sao Tome and Principe in 1973 to that in 1978?
Keep it short and to the point. 1. What is the ratio of the Area (in %) in Latin America(all income levels) in 1974 to that in 1975?
Make the answer very short. 0.99. What is the ratio of the Area (in %) in Sao Tome and Principe in 1974 to that in 1975?
Offer a terse response. 1. What is the ratio of the Area (in %) in Latin America(all income levels) in 1974 to that in 1976?
Your answer should be very brief. 0.97. What is the ratio of the Area (in %) of Middle East & North Africa (all income levels) in 1974 to that in 1976?
Your answer should be compact. 0.97. What is the ratio of the Area (in %) in Sao Tome and Principe in 1974 to that in 1976?
Give a very brief answer. 1. What is the ratio of the Area (in %) in Latin America(all income levels) in 1974 to that in 1977?
Your answer should be very brief. 0.95. What is the ratio of the Area (in %) in Middle East & North Africa (all income levels) in 1974 to that in 1977?
Provide a short and direct response. 0.95. What is the ratio of the Area (in %) in Latin America(all income levels) in 1974 to that in 1978?
Provide a succinct answer. 0.92. What is the ratio of the Area (in %) in Middle East & North Africa (all income levels) in 1974 to that in 1978?
Give a very brief answer. 0.95. What is the ratio of the Area (in %) of Benin in 1974 to that in 1978?
Give a very brief answer. 1. What is the ratio of the Area (in %) of Latin America(all income levels) in 1975 to that in 1976?
Your answer should be very brief. 0.98. What is the ratio of the Area (in %) of Middle East & North Africa (all income levels) in 1975 to that in 1976?
Provide a short and direct response. 0.98. What is the ratio of the Area (in %) in Benin in 1975 to that in 1976?
Provide a succinct answer. 1. What is the ratio of the Area (in %) in Sao Tome and Principe in 1975 to that in 1976?
Provide a succinct answer. 1. What is the ratio of the Area (in %) in Latin America(all income levels) in 1975 to that in 1977?
Offer a very short reply. 0.96. What is the ratio of the Area (in %) in Middle East & North Africa (all income levels) in 1975 to that in 1977?
Keep it short and to the point. 0.95. What is the ratio of the Area (in %) of Benin in 1975 to that in 1977?
Provide a short and direct response. 1. What is the ratio of the Area (in %) of Sao Tome and Principe in 1975 to that in 1977?
Ensure brevity in your answer.  1. What is the ratio of the Area (in %) of Latin America(all income levels) in 1975 to that in 1978?
Ensure brevity in your answer.  0.93. What is the ratio of the Area (in %) of Middle East & North Africa (all income levels) in 1975 to that in 1978?
Make the answer very short. 0.95. What is the ratio of the Area (in %) in Sao Tome and Principe in 1975 to that in 1978?
Provide a succinct answer. 1. What is the ratio of the Area (in %) of Latin America(all income levels) in 1976 to that in 1977?
Ensure brevity in your answer.  0.98. What is the ratio of the Area (in %) of Middle East & North Africa (all income levels) in 1976 to that in 1977?
Make the answer very short. 0.98. What is the ratio of the Area (in %) in Benin in 1976 to that in 1977?
Your answer should be compact. 1. What is the ratio of the Area (in %) in Latin America(all income levels) in 1976 to that in 1978?
Provide a succinct answer. 0.95. What is the ratio of the Area (in %) of Middle East & North Africa (all income levels) in 1976 to that in 1978?
Your answer should be compact. 0.98. What is the ratio of the Area (in %) of Benin in 1976 to that in 1978?
Give a very brief answer. 1. What is the ratio of the Area (in %) of Sao Tome and Principe in 1976 to that in 1978?
Offer a terse response. 1. What is the ratio of the Area (in %) of Latin America(all income levels) in 1977 to that in 1978?
Keep it short and to the point. 0.98. What is the ratio of the Area (in %) in Middle East & North Africa (all income levels) in 1977 to that in 1978?
Ensure brevity in your answer.  1. What is the ratio of the Area (in %) of Benin in 1977 to that in 1978?
Give a very brief answer. 1. What is the ratio of the Area (in %) in Sao Tome and Principe in 1977 to that in 1978?
Make the answer very short. 1. What is the difference between the highest and the second highest Area (in %) of Latin America(all income levels)?
Offer a terse response. 0.02. What is the difference between the highest and the lowest Area (in %) in Latin America(all income levels)?
Provide a succinct answer. 0.07. What is the difference between the highest and the lowest Area (in %) in Middle East & North Africa (all income levels)?
Give a very brief answer. 0.05. 